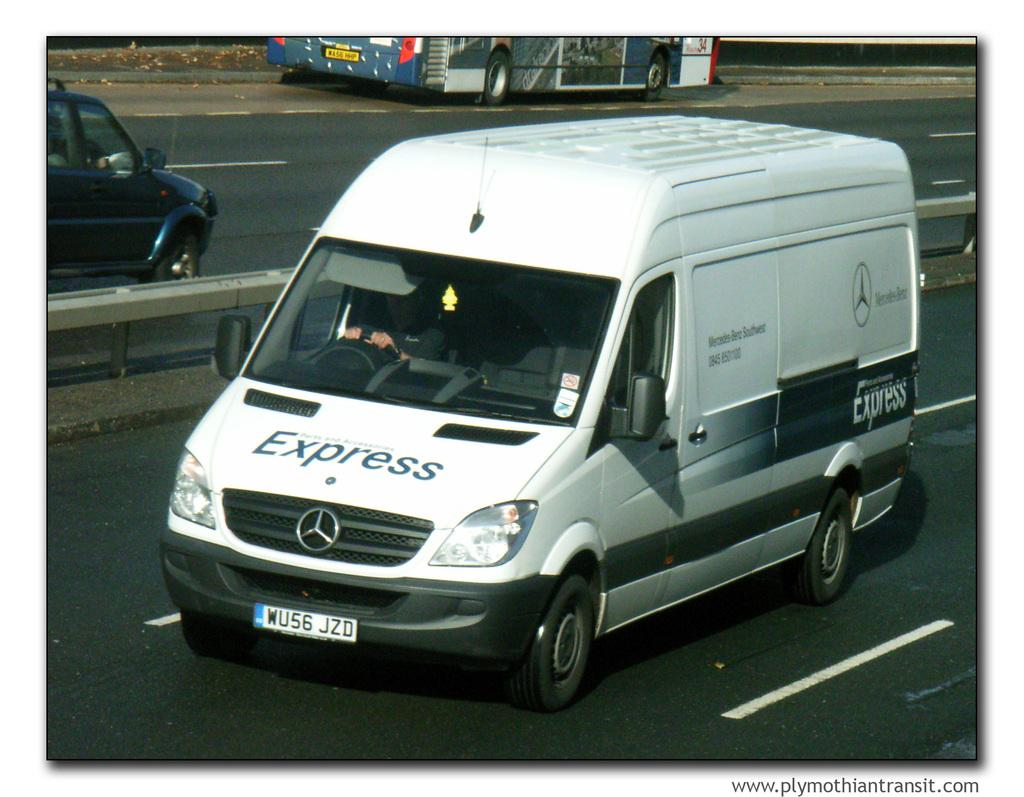What types of vehicles are in the image? There is a car, a van, and a bus in the image. Where are the vehicles located? The vehicles are on a road. Can you describe any features of the road? There appears to be a road divider in the image. Is there anyone inside any of the vehicles? Yes, there is a person sitting inside the van. Is there any additional information about the image? The image has a watermark. What type of tub can be seen in the image? There is no tub present in the image; it features a car, a van, and a bus on a road. Can you describe the punishment given to the vehicles for being on the road? There is no punishment given to the vehicles in the image, as they are simply parked or driving on the road. 